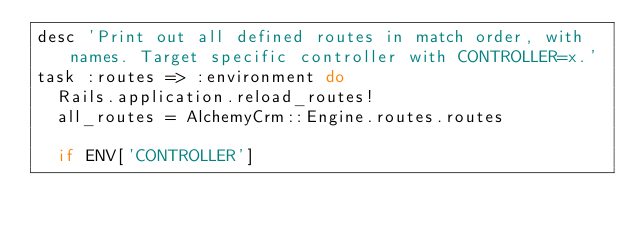Convert code to text. <code><loc_0><loc_0><loc_500><loc_500><_Ruby_>desc 'Print out all defined routes in match order, with names. Target specific controller with CONTROLLER=x.'
task :routes => :environment do
  Rails.application.reload_routes!
  all_routes = AlchemyCrm::Engine.routes.routes

  if ENV['CONTROLLER']</code> 